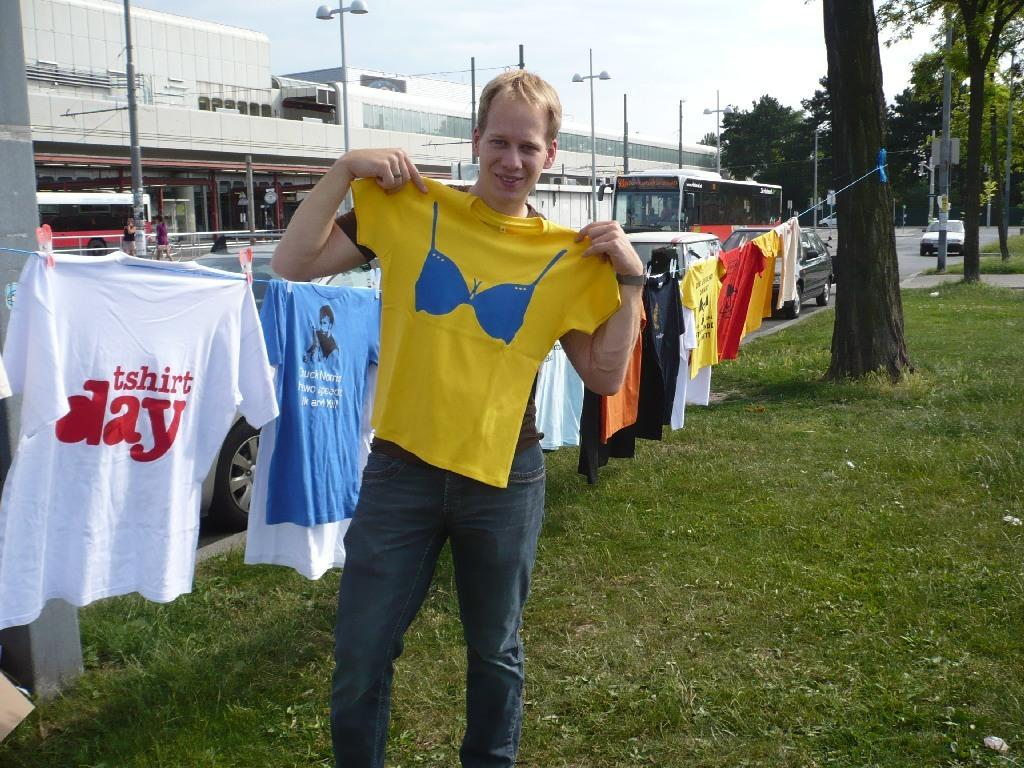Provide a one-sentence caption for the provided image. A collection of t-shirts hang on a line, one of them reading t-shirt day. 